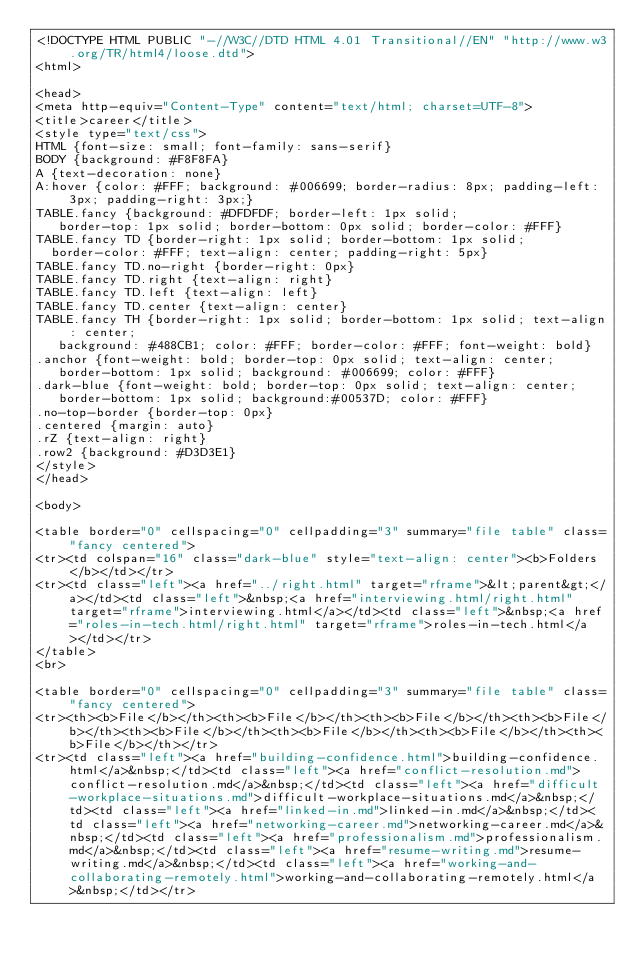Convert code to text. <code><loc_0><loc_0><loc_500><loc_500><_HTML_><!DOCTYPE HTML PUBLIC "-//W3C//DTD HTML 4.01 Transitional//EN" "http://www.w3.org/TR/html4/loose.dtd">
<html>

<head>
<meta http-equiv="Content-Type" content="text/html; charset=UTF-8">
<title>career</title>
<style type="text/css">
HTML {font-size: small; font-family: sans-serif}
BODY {background: #F8F8FA}
A {text-decoration: none}
A:hover {color: #FFF; background: #006699; border-radius: 8px; padding-left: 3px; padding-right: 3px;}
TABLE.fancy {background: #DFDFDF; border-left: 1px solid;
   border-top: 1px solid; border-bottom: 0px solid; border-color: #FFF}
TABLE.fancy TD {border-right: 1px solid; border-bottom: 1px solid;
  border-color: #FFF; text-align: center; padding-right: 5px}
TABLE.fancy TD.no-right {border-right: 0px}
TABLE.fancy TD.right {text-align: right}
TABLE.fancy TD.left {text-align: left}
TABLE.fancy TD.center {text-align: center}
TABLE.fancy TH {border-right: 1px solid; border-bottom: 1px solid; text-align: center;
   background: #488CB1; color: #FFF; border-color: #FFF; font-weight: bold}
.anchor {font-weight: bold; border-top: 0px solid; text-align: center;
   border-bottom: 1px solid; background: #006699; color: #FFF}
.dark-blue {font-weight: bold; border-top: 0px solid; text-align: center;
   border-bottom: 1px solid; background:#00537D; color: #FFF}
.no-top-border {border-top: 0px}
.centered {margin: auto}
.rZ {text-align: right}
.row2 {background: #D3D3E1}
</style>
</head>

<body>

<table border="0" cellspacing="0" cellpadding="3" summary="file table" class="fancy centered">
<tr><td colspan="16" class="dark-blue" style="text-align: center"><b>Folders</b></td></tr>
<tr><td class="left"><a href="../right.html" target="rframe">&lt;parent&gt;</a></td><td class="left">&nbsp;<a href="interviewing.html/right.html" target="rframe">interviewing.html</a></td><td class="left">&nbsp;<a href="roles-in-tech.html/right.html" target="rframe">roles-in-tech.html</a></td></tr>
</table>
<br>

<table border="0" cellspacing="0" cellpadding="3" summary="file table" class="fancy centered">
<tr><th><b>File</b></th><th><b>File</b></th><th><b>File</b></th><th><b>File</b></th><th><b>File</b></th><th><b>File</b></th><th><b>File</b></th><th><b>File</b></th></tr>
<tr><td class="left"><a href="building-confidence.html">building-confidence.html</a>&nbsp;</td><td class="left"><a href="conflict-resolution.md">conflict-resolution.md</a>&nbsp;</td><td class="left"><a href="difficult-workplace-situations.md">difficult-workplace-situations.md</a>&nbsp;</td><td class="left"><a href="linked-in.md">linked-in.md</a>&nbsp;</td><td class="left"><a href="networking-career.md">networking-career.md</a>&nbsp;</td><td class="left"><a href="professionalism.md">professionalism.md</a>&nbsp;</td><td class="left"><a href="resume-writing.md">resume-writing.md</a>&nbsp;</td><td class="left"><a href="working-and-collaborating-remotely.html">working-and-collaborating-remotely.html</a>&nbsp;</td></tr></code> 